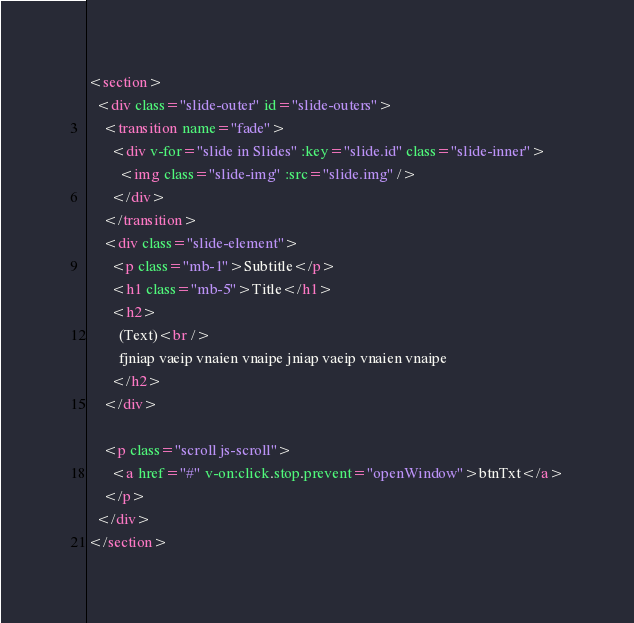Convert code to text. <code><loc_0><loc_0><loc_500><loc_500><_HTML_><section>
  <div class="slide-outer" id="slide-outers">
    <transition name="fade">
      <div v-for="slide in Slides" :key="slide.id" class="slide-inner">
        <img class="slide-img" :src="slide.img" />
      </div>
    </transition>
    <div class="slide-element">
      <p class="mb-1">Subtitle</p>
      <h1 class="mb-5">Title</h1>
      <h2>
        (Text)<br />
        fjniap vaeip vnaien vnaipe jniap vaeip vnaien vnaipe
      </h2>
    </div>

    <p class="scroll js-scroll">
      <a href="#" v-on:click.stop.prevent="openWindow">btnTxt</a>
    </p>
  </div>
</section>
</code> 